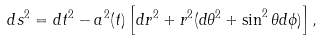<formula> <loc_0><loc_0><loc_500><loc_500>d s ^ { 2 } = d t ^ { 2 } - a ^ { 2 } ( t ) \left [ d r ^ { 2 } + r ^ { 2 } ( d \theta ^ { 2 } + \sin ^ { 2 } \theta d \phi ) \right ] ,</formula> 